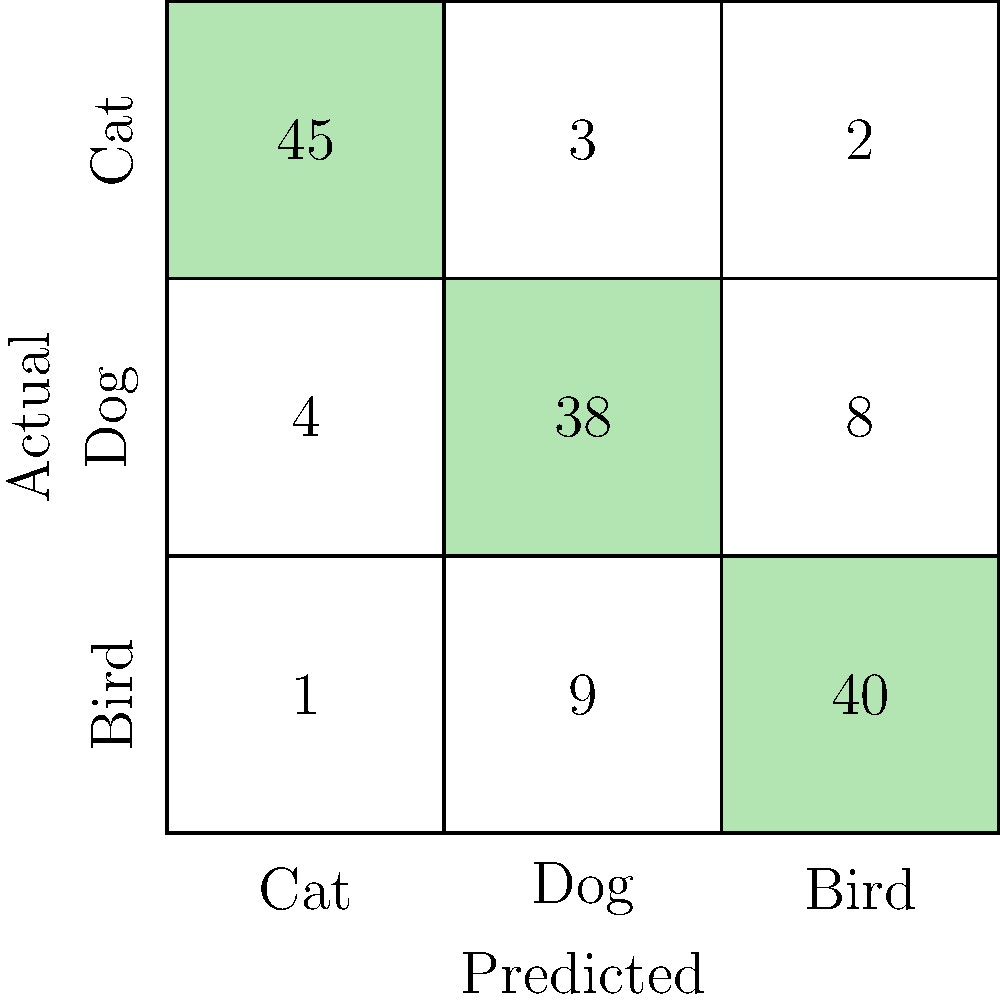Given the confusion matrix for a multi-class prediction model shown above, what is the precision for the "Dog" class? To calculate the precision for the "Dog" class, we need to follow these steps:

1. Identify the "Dog" column in the confusion matrix (middle column).
2. Find the true positive (TP) value for "Dog", which is the diagonal element: 38.
3. Calculate the sum of all predictions for "Dog" (column sum): 3 + 38 + 9 = 50.
4. Apply the precision formula: $\text{Precision} = \frac{\text{TP}}{\text{Total Predicted Positive}}$

Substituting the values:

$\text{Precision}_{\text{Dog}} = \frac{38}{50} = 0.76$

Therefore, the precision for the "Dog" class is 0.76 or 76%.
Answer: 0.76 